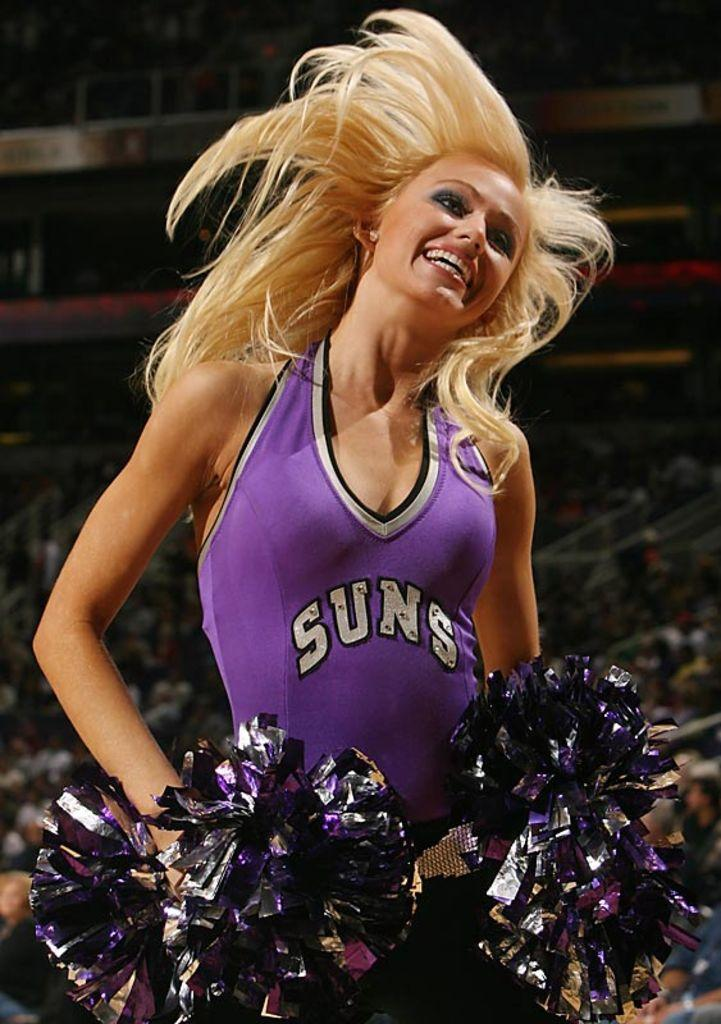<image>
Present a compact description of the photo's key features. A cheerleader with blonde hair wearing a purple uniform with the word Suns on the front. 